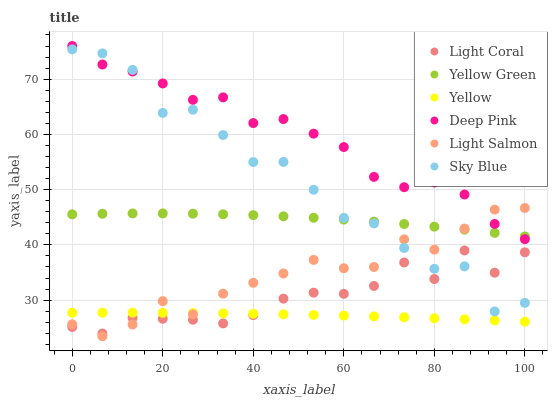Does Yellow have the minimum area under the curve?
Answer yes or no. Yes. Does Deep Pink have the maximum area under the curve?
Answer yes or no. Yes. Does Yellow Green have the minimum area under the curve?
Answer yes or no. No. Does Yellow Green have the maximum area under the curve?
Answer yes or no. No. Is Yellow the smoothest?
Answer yes or no. Yes. Is Sky Blue the roughest?
Answer yes or no. Yes. Is Deep Pink the smoothest?
Answer yes or no. No. Is Deep Pink the roughest?
Answer yes or no. No. Does Light Salmon have the lowest value?
Answer yes or no. Yes. Does Deep Pink have the lowest value?
Answer yes or no. No. Does Deep Pink have the highest value?
Answer yes or no. Yes. Does Yellow Green have the highest value?
Answer yes or no. No. Is Yellow less than Sky Blue?
Answer yes or no. Yes. Is Deep Pink greater than Yellow?
Answer yes or no. Yes. Does Light Salmon intersect Deep Pink?
Answer yes or no. Yes. Is Light Salmon less than Deep Pink?
Answer yes or no. No. Is Light Salmon greater than Deep Pink?
Answer yes or no. No. Does Yellow intersect Sky Blue?
Answer yes or no. No. 